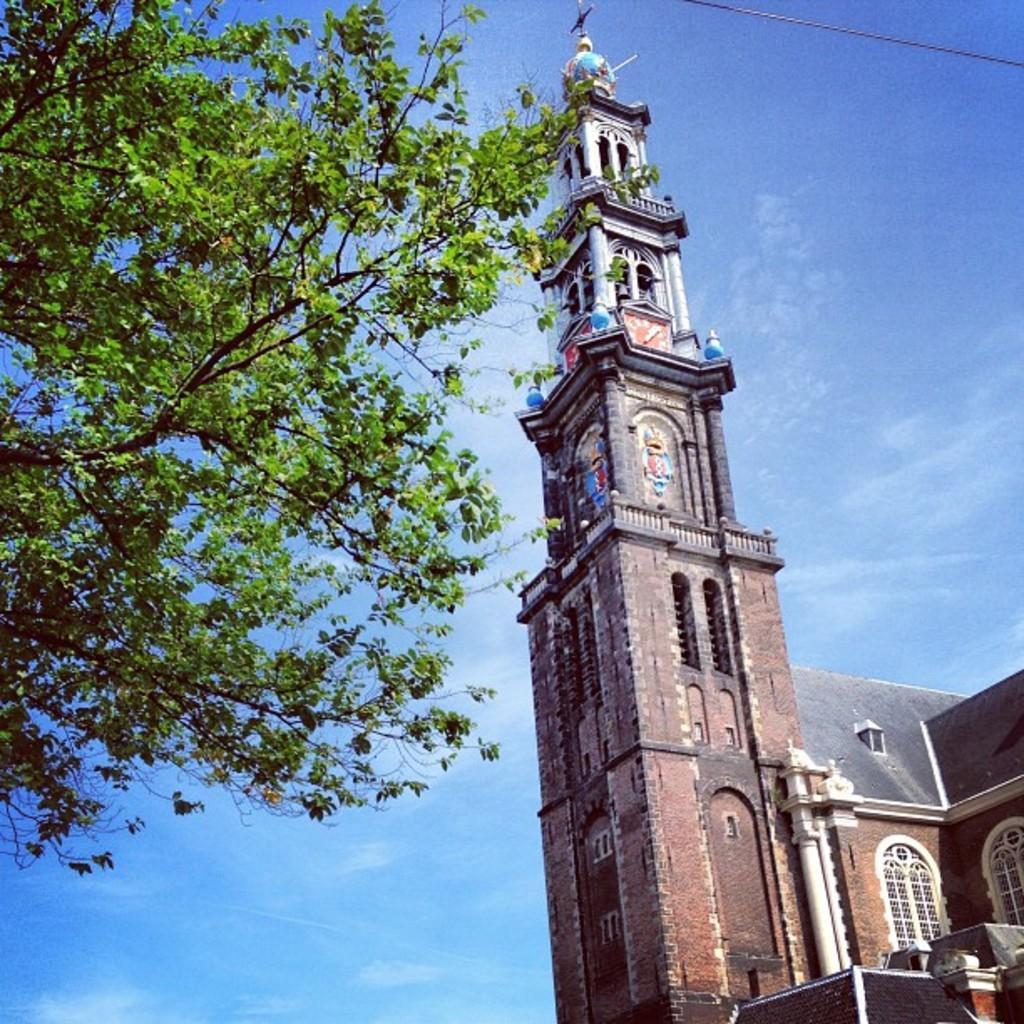Could you give a brief overview of what you see in this image? In this image, we can see a building and there is a tree on the left side, at the top there is a blue sky. 